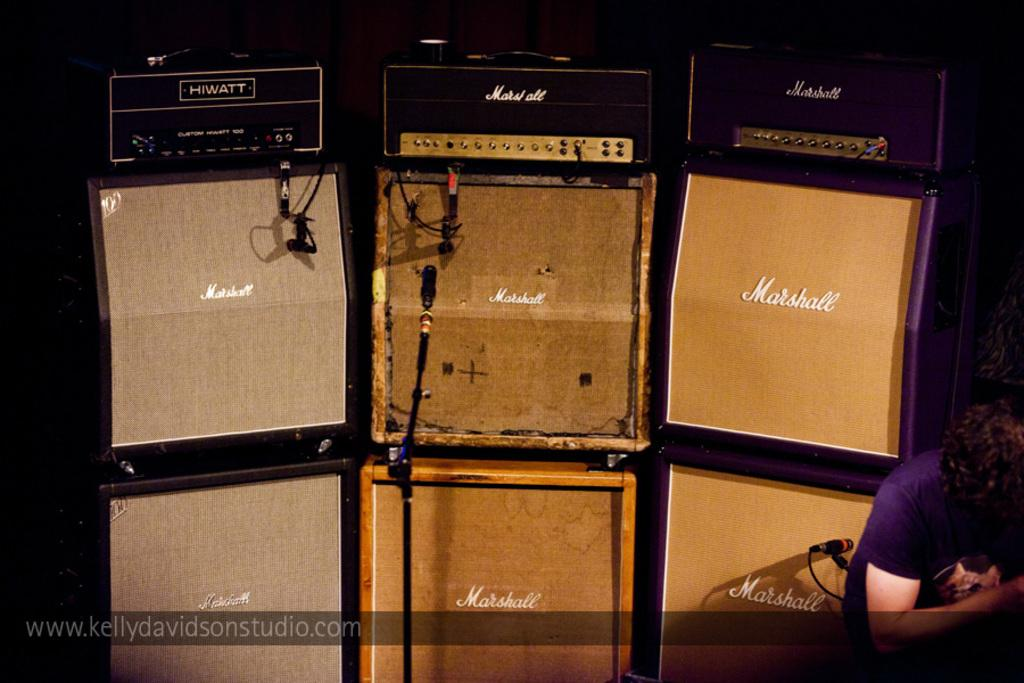What is located on the right side of the image? There is a person on the right side of the image. What objects can be seen in the image related to speaking or recording? There are microphones in the image. What type of furniture is present in the image for speakers to use? There are speech desks in the image. What type of island is visible in the image? There is no island present in the image. What part of the human body can be seen in the image? There is no specific part of the human body visible in the image; only a person is present. 